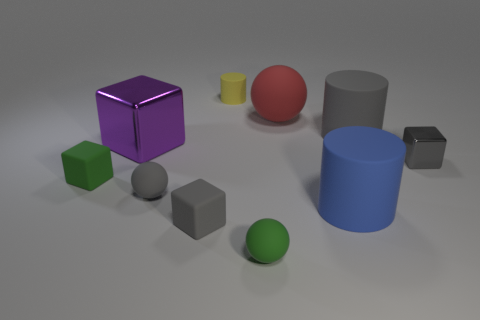Can you tell me what shapes are present and which one is the largest? Certainly! The shapes present in the image include a sphere, a cylinder, a cube, and there appears to be a small torus as well. The largest shape is the blue cylinder.  Are the green objects closer to each other than the red objects are to any of the cubes? The green cube and the green sphere are indeed closer to each other than any of the red objects are to any of the cubes. The two green shapes are almost adjacent, while the red sphere is spaced farther from the purple and gray cubes. 